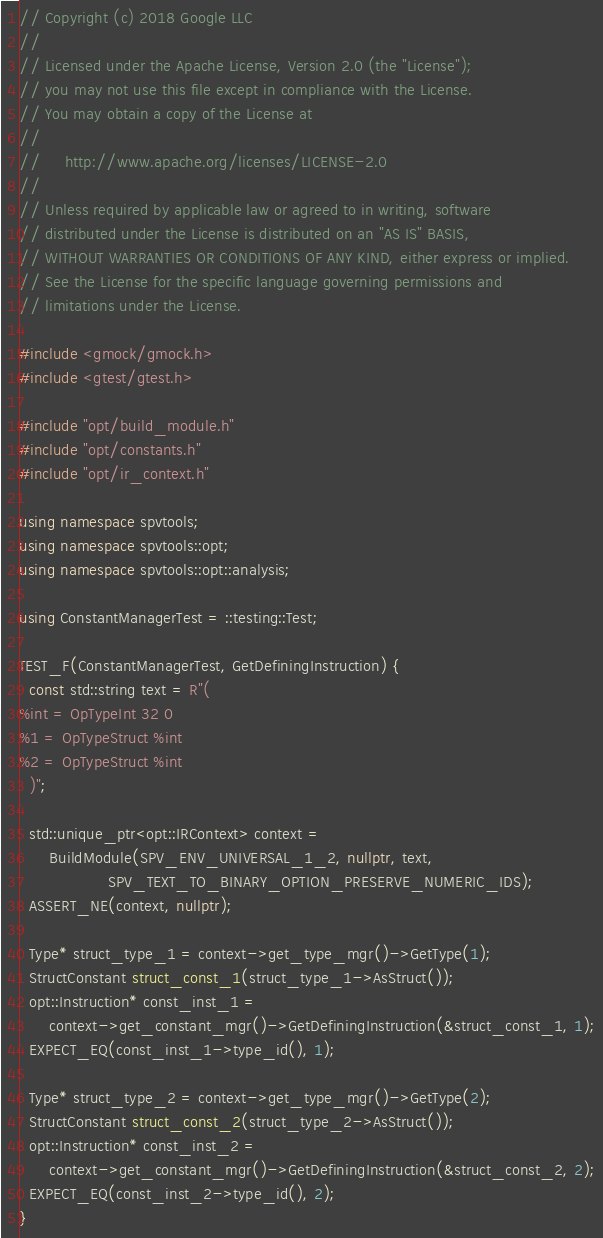<code> <loc_0><loc_0><loc_500><loc_500><_C++_>// Copyright (c) 2018 Google LLC
//
// Licensed under the Apache License, Version 2.0 (the "License");
// you may not use this file except in compliance with the License.
// You may obtain a copy of the License at
//
//     http://www.apache.org/licenses/LICENSE-2.0
//
// Unless required by applicable law or agreed to in writing, software
// distributed under the License is distributed on an "AS IS" BASIS,
// WITHOUT WARRANTIES OR CONDITIONS OF ANY KIND, either express or implied.
// See the License for the specific language governing permissions and
// limitations under the License.

#include <gmock/gmock.h>
#include <gtest/gtest.h>

#include "opt/build_module.h"
#include "opt/constants.h"
#include "opt/ir_context.h"

using namespace spvtools;
using namespace spvtools::opt;
using namespace spvtools::opt::analysis;

using ConstantManagerTest = ::testing::Test;

TEST_F(ConstantManagerTest, GetDefiningInstruction) {
  const std::string text = R"(
%int = OpTypeInt 32 0
%1 = OpTypeStruct %int
%2 = OpTypeStruct %int
  )";

  std::unique_ptr<opt::IRContext> context =
      BuildModule(SPV_ENV_UNIVERSAL_1_2, nullptr, text,
                  SPV_TEXT_TO_BINARY_OPTION_PRESERVE_NUMERIC_IDS);
  ASSERT_NE(context, nullptr);

  Type* struct_type_1 = context->get_type_mgr()->GetType(1);
  StructConstant struct_const_1(struct_type_1->AsStruct());
  opt::Instruction* const_inst_1 =
      context->get_constant_mgr()->GetDefiningInstruction(&struct_const_1, 1);
  EXPECT_EQ(const_inst_1->type_id(), 1);

  Type* struct_type_2 = context->get_type_mgr()->GetType(2);
  StructConstant struct_const_2(struct_type_2->AsStruct());
  opt::Instruction* const_inst_2 =
      context->get_constant_mgr()->GetDefiningInstruction(&struct_const_2, 2);
  EXPECT_EQ(const_inst_2->type_id(), 2);
}
</code> 